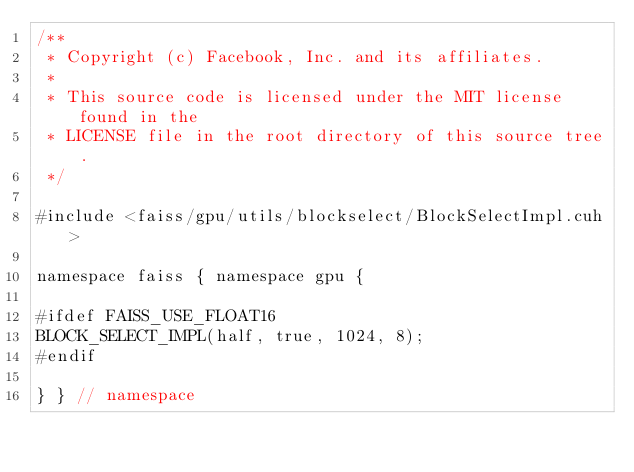Convert code to text. <code><loc_0><loc_0><loc_500><loc_500><_Cuda_>/**
 * Copyright (c) Facebook, Inc. and its affiliates.
 *
 * This source code is licensed under the MIT license found in the
 * LICENSE file in the root directory of this source tree.
 */

#include <faiss/gpu/utils/blockselect/BlockSelectImpl.cuh>

namespace faiss { namespace gpu {

#ifdef FAISS_USE_FLOAT16
BLOCK_SELECT_IMPL(half, true, 1024, 8);
#endif

} } // namespace
</code> 